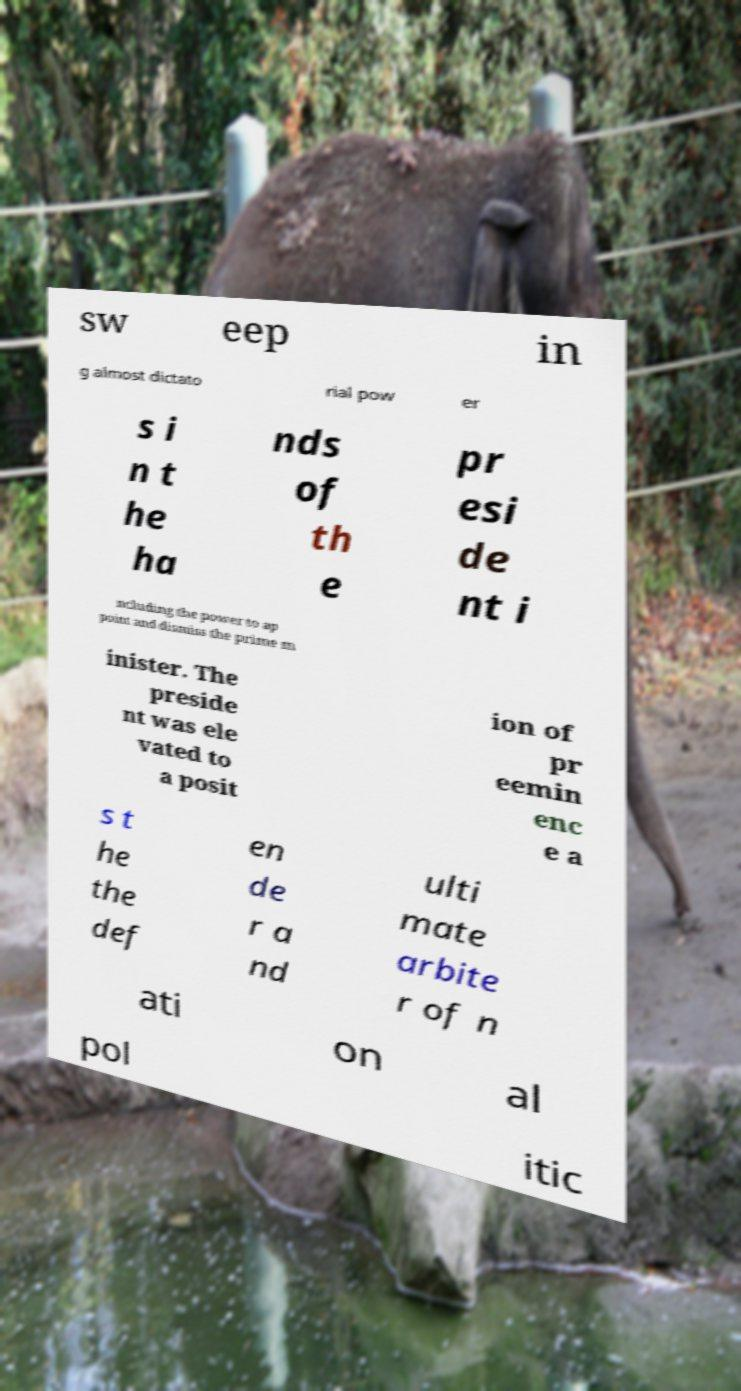For documentation purposes, I need the text within this image transcribed. Could you provide that? sw eep in g almost dictato rial pow er s i n t he ha nds of th e pr esi de nt i ncluding the power to ap point and dismiss the prime m inister. The preside nt was ele vated to a posit ion of pr eemin enc e a s t he the def en de r a nd ulti mate arbite r of n ati on al pol itic 